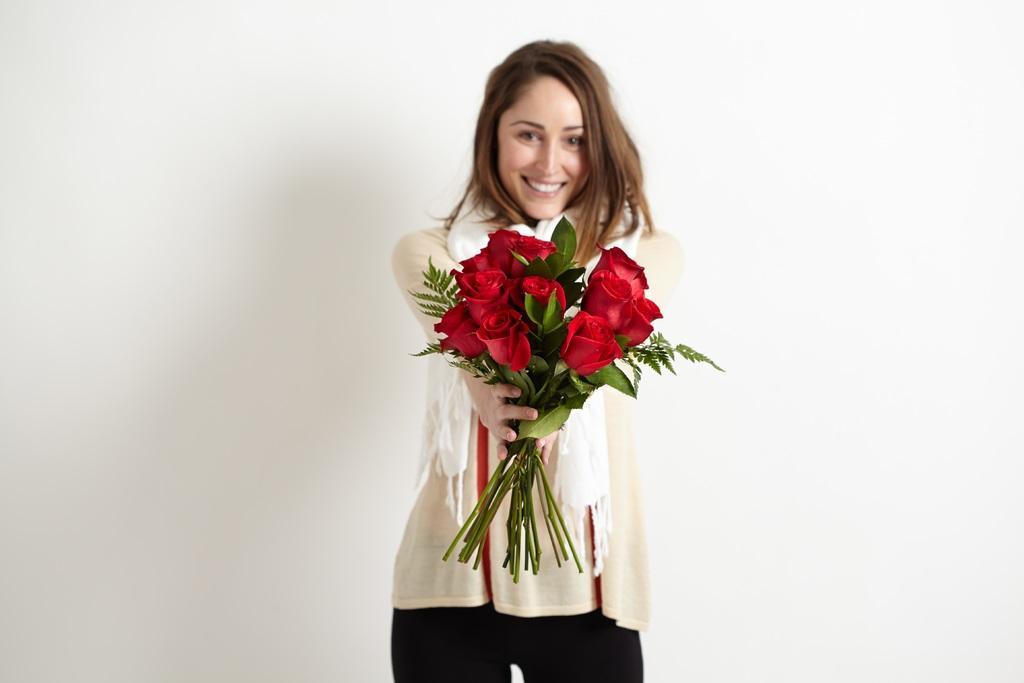In one or two sentences, can you explain what this image depicts? In this image we can see a woman and the woman is holding flowers. The background of his image is white. 